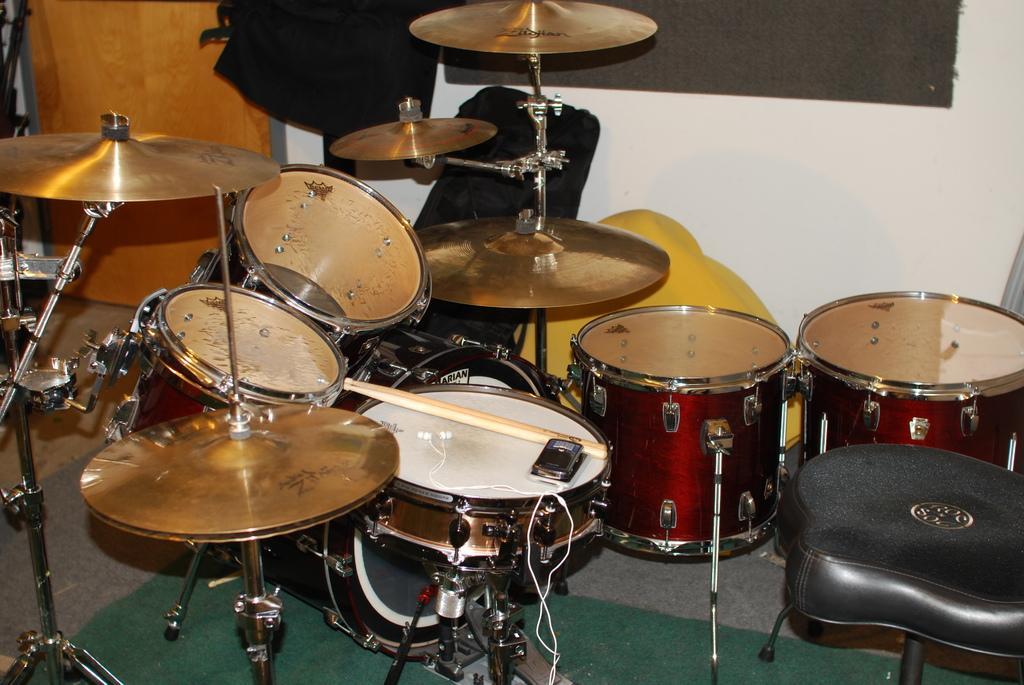Describe this image in one or two sentences. In this image I can see the floor, a green colored carpet on the floor and number of musical instruments. I can see the black colored seat, the white colored wall, the brown colored door and few black and yellow colored objects. 